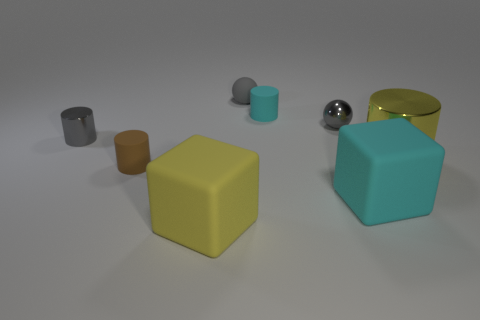What is the material of the other sphere that is the same color as the tiny rubber sphere?
Provide a succinct answer. Metal. There is a tiny cylinder that is on the left side of the small cyan thing and behind the small brown matte cylinder; what is it made of?
Provide a succinct answer. Metal. What is the color of the big metallic cylinder?
Offer a terse response. Yellow. Are there any other things that have the same material as the gray cylinder?
Your answer should be very brief. Yes. There is a cyan object in front of the big yellow cylinder; what is its shape?
Your answer should be very brief. Cube. Is there a cyan matte cylinder on the left side of the big matte cube to the right of the gray metallic thing behind the gray metallic cylinder?
Your answer should be very brief. Yes. Are there any other things that have the same shape as the large cyan thing?
Offer a terse response. Yes. Is there a small green cylinder?
Your response must be concise. No. Do the tiny cylinder that is in front of the large yellow cylinder and the large yellow thing left of the yellow cylinder have the same material?
Make the answer very short. Yes. There is a gray thing right of the small cylinder that is behind the gray object that is to the left of the small brown thing; what is its size?
Offer a very short reply. Small. 